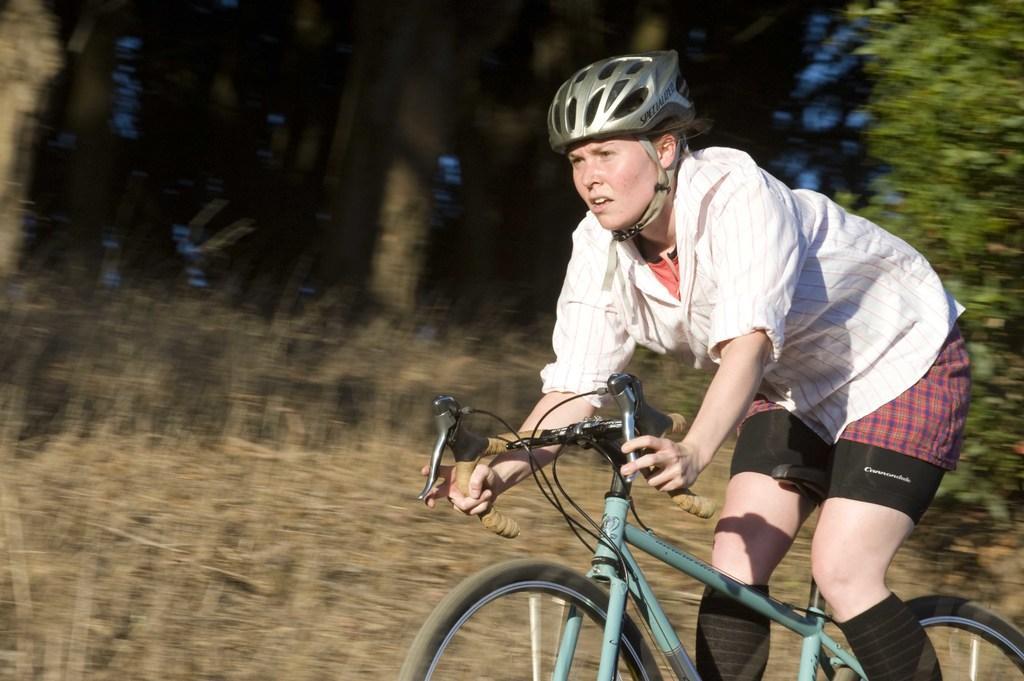Describe this image in one or two sentences. In the foreground of the picture there is a woman riding a bicycle. The background is blurred. In the background there are shrubs and trees. It is a sunny day. 